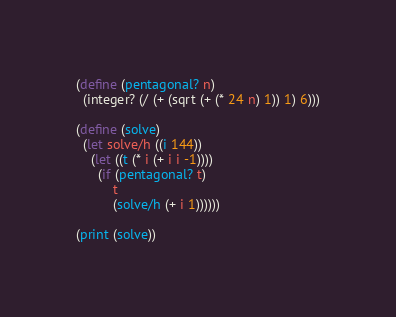Convert code to text. <code><loc_0><loc_0><loc_500><loc_500><_Scheme_>(define (pentagonal? n)
  (integer? (/ (+ (sqrt (+ (* 24 n) 1)) 1) 6)))

(define (solve)
  (let solve/h ((i 144))
    (let ((t (* i (+ i i -1))))
      (if (pentagonal? t)
          t
          (solve/h (+ i 1))))))

(print (solve))
</code> 